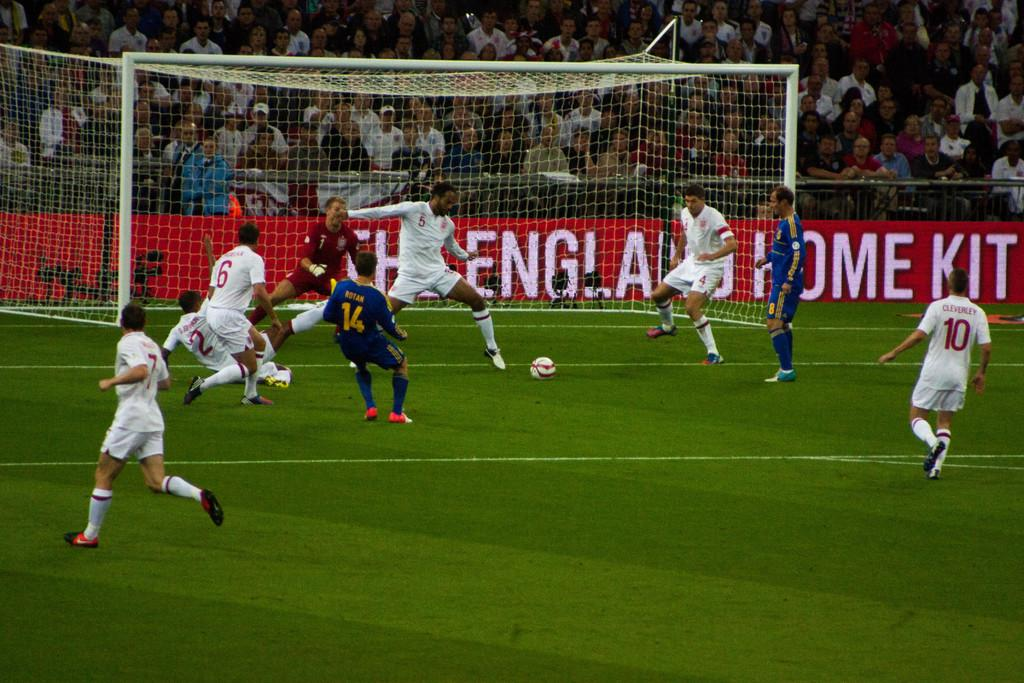<image>
Present a compact description of the photo's key features. Soccer players playing game on the field including the one named Rotan. 